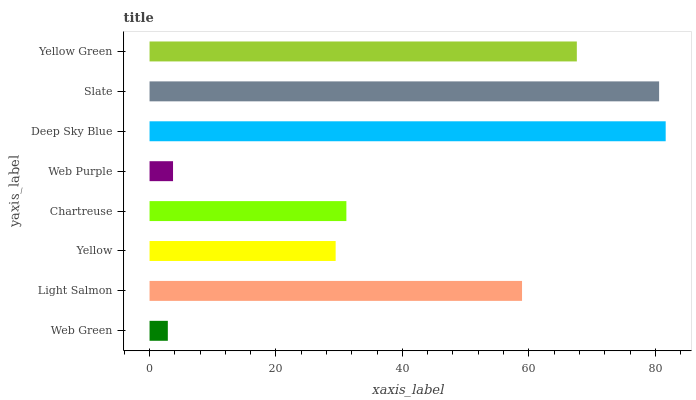Is Web Green the minimum?
Answer yes or no. Yes. Is Deep Sky Blue the maximum?
Answer yes or no. Yes. Is Light Salmon the minimum?
Answer yes or no. No. Is Light Salmon the maximum?
Answer yes or no. No. Is Light Salmon greater than Web Green?
Answer yes or no. Yes. Is Web Green less than Light Salmon?
Answer yes or no. Yes. Is Web Green greater than Light Salmon?
Answer yes or no. No. Is Light Salmon less than Web Green?
Answer yes or no. No. Is Light Salmon the high median?
Answer yes or no. Yes. Is Chartreuse the low median?
Answer yes or no. Yes. Is Slate the high median?
Answer yes or no. No. Is Deep Sky Blue the low median?
Answer yes or no. No. 